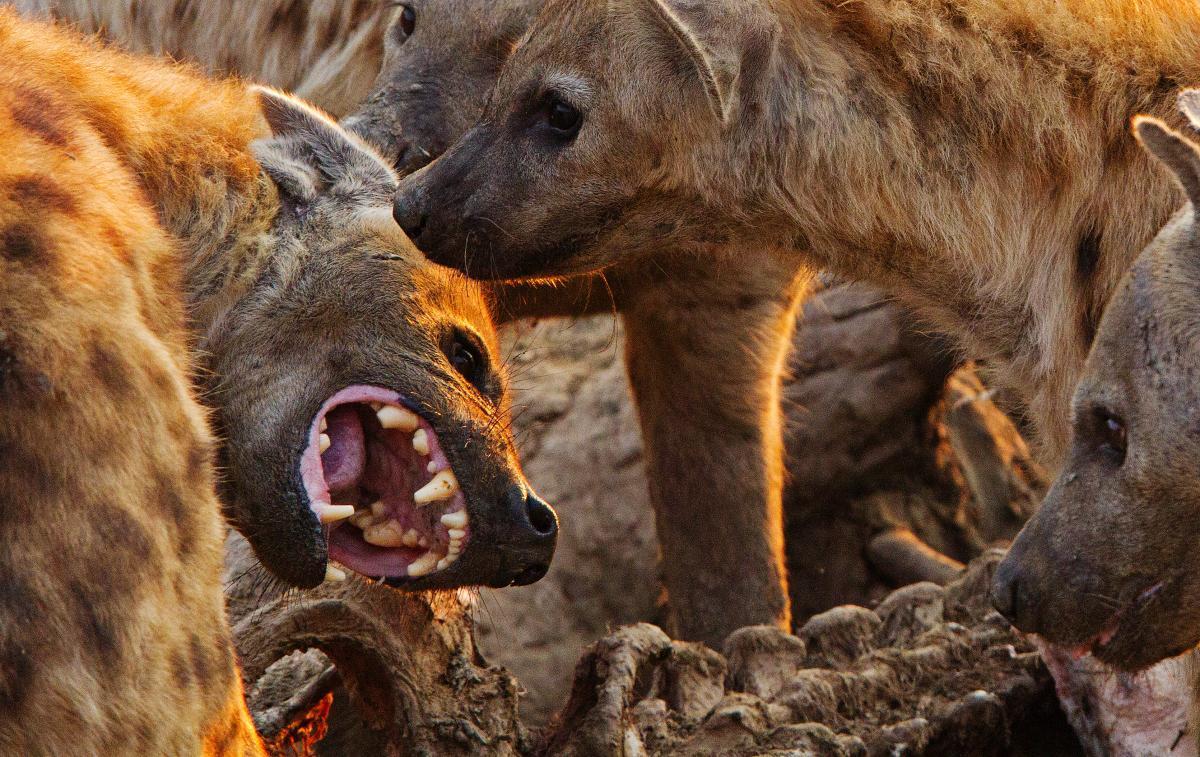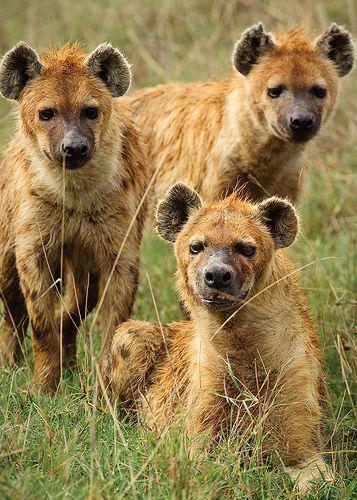The first image is the image on the left, the second image is the image on the right. For the images shown, is this caption "The right image contains at least two animals." true? Answer yes or no. Yes. The first image is the image on the left, the second image is the image on the right. For the images displayed, is the sentence "The lefthand image includes a lion, and the righthand image contains only a fang-baring hyena." factually correct? Answer yes or no. No. 